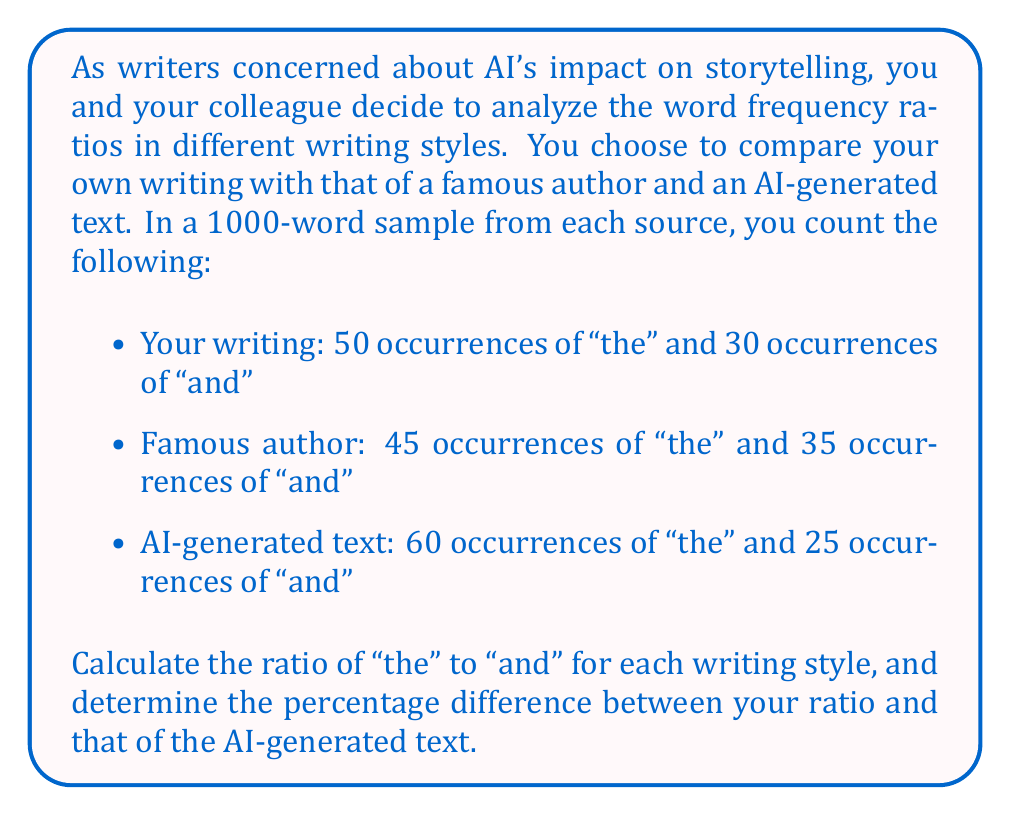Can you answer this question? To solve this problem, we'll follow these steps:

1. Calculate the ratio of "the" to "and" for each writing style.
2. Compare your ratio to the AI-generated text ratio.
3. Calculate the percentage difference.

Step 1: Calculate the ratios

For your writing:
$$ \text{Your ratio} = \frac{\text{occurrences of "the"}}{\text{occurrences of "and"}} = \frac{50}{30} = \frac{5}{3} \approx 1.67 $$

For the famous author:
$$ \text{Author ratio} = \frac{45}{35} = \frac{9}{7} \approx 1.29 $$

For the AI-generated text:
$$ \text{AI ratio} = \frac{60}{25} = \frac{12}{5} = 2.4 $$

Step 2: Compare your ratio to the AI-generated text ratio

The difference between the ratios:
$$ \text{Difference} = \text{AI ratio} - \text{Your ratio} = 2.4 - \frac{5}{3} = 2.4 - 1.67 = 0.73 $$

Step 3: Calculate the percentage difference

To calculate the percentage difference, we use the formula:

$$ \text{Percentage difference} = \frac{\text{Difference}}{\text{Your ratio}} \times 100\% $$

Substituting the values:

$$ \text{Percentage difference} = \frac{0.73}{\frac{5}{3}} \times 100\% = \frac{0.73 \times 3}{5} \times 100\% = 43.8\% $$
Answer: The ratio of "the" to "and" in your writing is $\frac{5}{3}$ (approximately 1.67), and the ratio in the AI-generated text is 2.4. The percentage difference between your ratio and the AI-generated text ratio is 43.8%. 